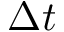<formula> <loc_0><loc_0><loc_500><loc_500>\Delta t</formula> 